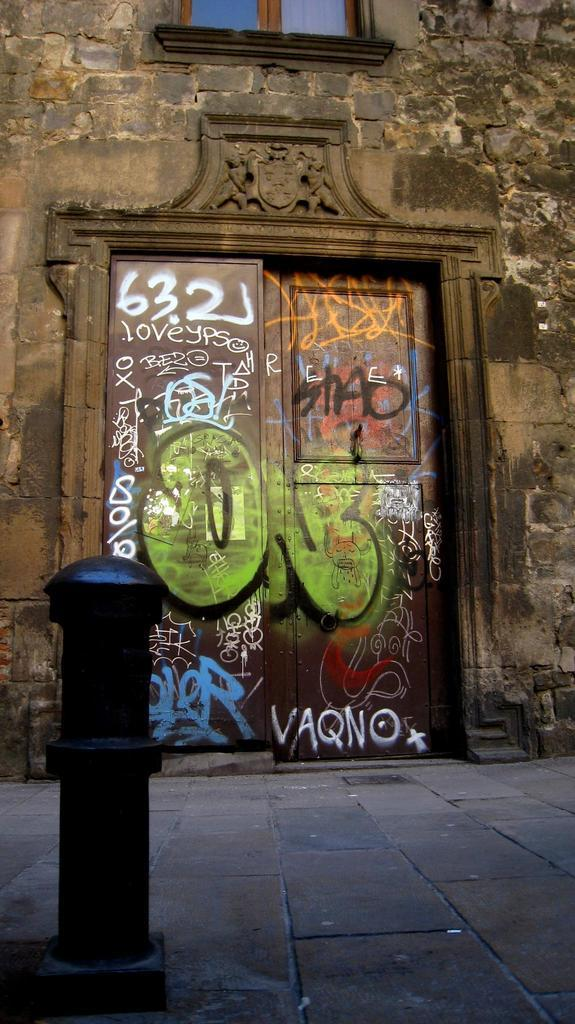What type of openings can be seen in the image? There are windows in the image. What type of structure is visible in the image? There is a wall in the image. Is there a way to enter or exit the structure in the image? Yes, there is a door in the image. What is located on the ground in the image? There is an object on the ground in the image. Reasoning: Let's think step by step by step in order to produce the conversation. We start by identifying the main subjects and objects in the image based on the provided facts. We then formulate questions that focus on the location and characteristics of these subjects and objects, ensuring that each question can be answered definitively with the information given. We avoid yes/no questions and ensure that the language is simple and clear. Absurd Question/Answer: What type of government is depicted in the image? There is no depiction of a government in the image; it features windows, a wall, a door, and an object on the ground. How many tomatoes are visible in the image? There are no tomatoes present in the image. How many tomatoes are visible in the image? There are no tomatoes present in the image. --- Facts: 1. There is a person in the image. 2. The person is holding a book. 3. The person is sitting on a chair. 4. There is a table in the image. 5. The table has a lamp on it. Absurd Topics: dance, ocean, dinosaur Conversation: Who is present in the image? There is a person in the image. What is the person holding? The person is holding a book. What is the person sitting on? The person is sitting on a chair. What is on the table in the image? The table has a lamp on it. Reasoning: Let's think step by step in order to produce the conversation. We start by identifying the main subject in the image, which is the person. Then, we expand the conversation to include other items that are also visible, such as the book, chair, table, and lamp. Each question is designed to elicit a specific detail about the image that is known from the provided facts. Absurd Question/Answer: What type of dance is the person performing in the image? There is no indication of dancing in the image 